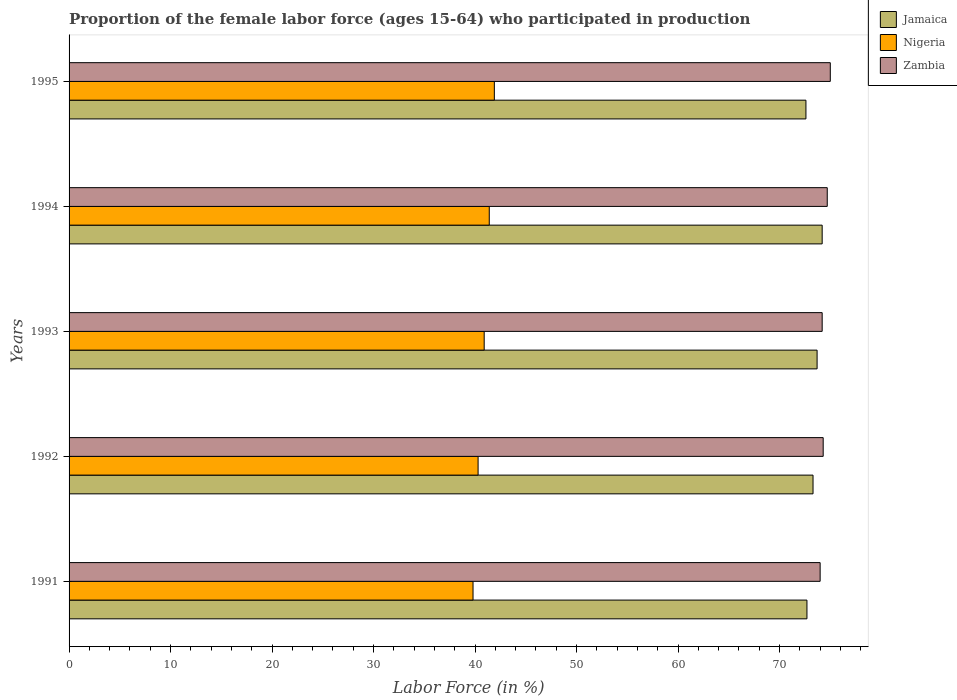How many groups of bars are there?
Provide a succinct answer. 5. How many bars are there on the 1st tick from the bottom?
Your answer should be very brief. 3. What is the label of the 1st group of bars from the top?
Keep it short and to the point. 1995. What is the proportion of the female labor force who participated in production in Nigeria in 1991?
Ensure brevity in your answer.  39.8. Across all years, what is the minimum proportion of the female labor force who participated in production in Zambia?
Offer a very short reply. 74. In which year was the proportion of the female labor force who participated in production in Nigeria maximum?
Keep it short and to the point. 1995. In which year was the proportion of the female labor force who participated in production in Zambia minimum?
Provide a succinct answer. 1991. What is the total proportion of the female labor force who participated in production in Nigeria in the graph?
Ensure brevity in your answer.  204.3. What is the difference between the proportion of the female labor force who participated in production in Jamaica in 1994 and that in 1995?
Offer a terse response. 1.6. What is the difference between the proportion of the female labor force who participated in production in Zambia in 1994 and the proportion of the female labor force who participated in production in Nigeria in 1991?
Keep it short and to the point. 34.9. What is the average proportion of the female labor force who participated in production in Zambia per year?
Keep it short and to the point. 74.44. In the year 1993, what is the difference between the proportion of the female labor force who participated in production in Zambia and proportion of the female labor force who participated in production in Nigeria?
Your answer should be very brief. 33.3. What is the ratio of the proportion of the female labor force who participated in production in Jamaica in 1991 to that in 1994?
Provide a short and direct response. 0.98. What is the difference between the highest and the lowest proportion of the female labor force who participated in production in Nigeria?
Your response must be concise. 2.1. In how many years, is the proportion of the female labor force who participated in production in Nigeria greater than the average proportion of the female labor force who participated in production in Nigeria taken over all years?
Offer a terse response. 3. Is the sum of the proportion of the female labor force who participated in production in Nigeria in 1993 and 1994 greater than the maximum proportion of the female labor force who participated in production in Zambia across all years?
Make the answer very short. Yes. What does the 3rd bar from the top in 1992 represents?
Make the answer very short. Jamaica. What does the 2nd bar from the bottom in 1994 represents?
Your answer should be very brief. Nigeria. Is it the case that in every year, the sum of the proportion of the female labor force who participated in production in Jamaica and proportion of the female labor force who participated in production in Nigeria is greater than the proportion of the female labor force who participated in production in Zambia?
Make the answer very short. Yes. How many bars are there?
Make the answer very short. 15. Are all the bars in the graph horizontal?
Make the answer very short. Yes. How many years are there in the graph?
Offer a very short reply. 5. What is the difference between two consecutive major ticks on the X-axis?
Your answer should be very brief. 10. Are the values on the major ticks of X-axis written in scientific E-notation?
Give a very brief answer. No. Where does the legend appear in the graph?
Offer a very short reply. Top right. How many legend labels are there?
Your answer should be compact. 3. What is the title of the graph?
Offer a very short reply. Proportion of the female labor force (ages 15-64) who participated in production. Does "Cabo Verde" appear as one of the legend labels in the graph?
Keep it short and to the point. No. What is the Labor Force (in %) in Jamaica in 1991?
Your answer should be very brief. 72.7. What is the Labor Force (in %) in Nigeria in 1991?
Provide a succinct answer. 39.8. What is the Labor Force (in %) of Jamaica in 1992?
Offer a terse response. 73.3. What is the Labor Force (in %) in Nigeria in 1992?
Your answer should be very brief. 40.3. What is the Labor Force (in %) of Zambia in 1992?
Your answer should be very brief. 74.3. What is the Labor Force (in %) in Jamaica in 1993?
Offer a terse response. 73.7. What is the Labor Force (in %) in Nigeria in 1993?
Provide a short and direct response. 40.9. What is the Labor Force (in %) of Zambia in 1993?
Provide a succinct answer. 74.2. What is the Labor Force (in %) in Jamaica in 1994?
Give a very brief answer. 74.2. What is the Labor Force (in %) of Nigeria in 1994?
Make the answer very short. 41.4. What is the Labor Force (in %) of Zambia in 1994?
Ensure brevity in your answer.  74.7. What is the Labor Force (in %) of Jamaica in 1995?
Offer a very short reply. 72.6. What is the Labor Force (in %) of Nigeria in 1995?
Offer a terse response. 41.9. What is the Labor Force (in %) in Zambia in 1995?
Offer a very short reply. 75. Across all years, what is the maximum Labor Force (in %) in Jamaica?
Keep it short and to the point. 74.2. Across all years, what is the maximum Labor Force (in %) of Nigeria?
Your response must be concise. 41.9. Across all years, what is the minimum Labor Force (in %) of Jamaica?
Your answer should be compact. 72.6. Across all years, what is the minimum Labor Force (in %) of Nigeria?
Your answer should be compact. 39.8. Across all years, what is the minimum Labor Force (in %) of Zambia?
Ensure brevity in your answer.  74. What is the total Labor Force (in %) of Jamaica in the graph?
Offer a terse response. 366.5. What is the total Labor Force (in %) in Nigeria in the graph?
Offer a terse response. 204.3. What is the total Labor Force (in %) in Zambia in the graph?
Give a very brief answer. 372.2. What is the difference between the Labor Force (in %) of Jamaica in 1991 and that in 1992?
Give a very brief answer. -0.6. What is the difference between the Labor Force (in %) in Zambia in 1991 and that in 1992?
Your response must be concise. -0.3. What is the difference between the Labor Force (in %) in Jamaica in 1991 and that in 1993?
Offer a terse response. -1. What is the difference between the Labor Force (in %) of Nigeria in 1991 and that in 1993?
Ensure brevity in your answer.  -1.1. What is the difference between the Labor Force (in %) of Zambia in 1991 and that in 1993?
Ensure brevity in your answer.  -0.2. What is the difference between the Labor Force (in %) of Jamaica in 1991 and that in 1994?
Give a very brief answer. -1.5. What is the difference between the Labor Force (in %) in Nigeria in 1991 and that in 1994?
Keep it short and to the point. -1.6. What is the difference between the Labor Force (in %) in Zambia in 1991 and that in 1994?
Your answer should be very brief. -0.7. What is the difference between the Labor Force (in %) in Nigeria in 1991 and that in 1995?
Ensure brevity in your answer.  -2.1. What is the difference between the Labor Force (in %) of Zambia in 1991 and that in 1995?
Give a very brief answer. -1. What is the difference between the Labor Force (in %) in Zambia in 1992 and that in 1993?
Keep it short and to the point. 0.1. What is the difference between the Labor Force (in %) of Jamaica in 1992 and that in 1994?
Your answer should be compact. -0.9. What is the difference between the Labor Force (in %) in Nigeria in 1992 and that in 1995?
Make the answer very short. -1.6. What is the difference between the Labor Force (in %) of Zambia in 1992 and that in 1995?
Provide a succinct answer. -0.7. What is the difference between the Labor Force (in %) of Jamaica in 1993 and that in 1994?
Offer a very short reply. -0.5. What is the difference between the Labor Force (in %) of Zambia in 1993 and that in 1994?
Your answer should be very brief. -0.5. What is the difference between the Labor Force (in %) of Nigeria in 1993 and that in 1995?
Keep it short and to the point. -1. What is the difference between the Labor Force (in %) in Jamaica in 1991 and the Labor Force (in %) in Nigeria in 1992?
Provide a short and direct response. 32.4. What is the difference between the Labor Force (in %) in Jamaica in 1991 and the Labor Force (in %) in Zambia in 1992?
Make the answer very short. -1.6. What is the difference between the Labor Force (in %) of Nigeria in 1991 and the Labor Force (in %) of Zambia in 1992?
Your answer should be very brief. -34.5. What is the difference between the Labor Force (in %) of Jamaica in 1991 and the Labor Force (in %) of Nigeria in 1993?
Your answer should be very brief. 31.8. What is the difference between the Labor Force (in %) of Nigeria in 1991 and the Labor Force (in %) of Zambia in 1993?
Provide a succinct answer. -34.4. What is the difference between the Labor Force (in %) in Jamaica in 1991 and the Labor Force (in %) in Nigeria in 1994?
Offer a terse response. 31.3. What is the difference between the Labor Force (in %) of Jamaica in 1991 and the Labor Force (in %) of Zambia in 1994?
Provide a short and direct response. -2. What is the difference between the Labor Force (in %) of Nigeria in 1991 and the Labor Force (in %) of Zambia in 1994?
Make the answer very short. -34.9. What is the difference between the Labor Force (in %) in Jamaica in 1991 and the Labor Force (in %) in Nigeria in 1995?
Keep it short and to the point. 30.8. What is the difference between the Labor Force (in %) in Jamaica in 1991 and the Labor Force (in %) in Zambia in 1995?
Offer a terse response. -2.3. What is the difference between the Labor Force (in %) in Nigeria in 1991 and the Labor Force (in %) in Zambia in 1995?
Provide a succinct answer. -35.2. What is the difference between the Labor Force (in %) in Jamaica in 1992 and the Labor Force (in %) in Nigeria in 1993?
Make the answer very short. 32.4. What is the difference between the Labor Force (in %) in Jamaica in 1992 and the Labor Force (in %) in Zambia in 1993?
Offer a terse response. -0.9. What is the difference between the Labor Force (in %) of Nigeria in 1992 and the Labor Force (in %) of Zambia in 1993?
Offer a very short reply. -33.9. What is the difference between the Labor Force (in %) of Jamaica in 1992 and the Labor Force (in %) of Nigeria in 1994?
Provide a short and direct response. 31.9. What is the difference between the Labor Force (in %) in Nigeria in 1992 and the Labor Force (in %) in Zambia in 1994?
Give a very brief answer. -34.4. What is the difference between the Labor Force (in %) of Jamaica in 1992 and the Labor Force (in %) of Nigeria in 1995?
Your response must be concise. 31.4. What is the difference between the Labor Force (in %) in Nigeria in 1992 and the Labor Force (in %) in Zambia in 1995?
Give a very brief answer. -34.7. What is the difference between the Labor Force (in %) in Jamaica in 1993 and the Labor Force (in %) in Nigeria in 1994?
Ensure brevity in your answer.  32.3. What is the difference between the Labor Force (in %) of Jamaica in 1993 and the Labor Force (in %) of Zambia in 1994?
Offer a terse response. -1. What is the difference between the Labor Force (in %) of Nigeria in 1993 and the Labor Force (in %) of Zambia in 1994?
Provide a short and direct response. -33.8. What is the difference between the Labor Force (in %) in Jamaica in 1993 and the Labor Force (in %) in Nigeria in 1995?
Provide a short and direct response. 31.8. What is the difference between the Labor Force (in %) of Jamaica in 1993 and the Labor Force (in %) of Zambia in 1995?
Offer a terse response. -1.3. What is the difference between the Labor Force (in %) of Nigeria in 1993 and the Labor Force (in %) of Zambia in 1995?
Your answer should be compact. -34.1. What is the difference between the Labor Force (in %) in Jamaica in 1994 and the Labor Force (in %) in Nigeria in 1995?
Offer a very short reply. 32.3. What is the difference between the Labor Force (in %) in Jamaica in 1994 and the Labor Force (in %) in Zambia in 1995?
Your answer should be compact. -0.8. What is the difference between the Labor Force (in %) in Nigeria in 1994 and the Labor Force (in %) in Zambia in 1995?
Offer a very short reply. -33.6. What is the average Labor Force (in %) of Jamaica per year?
Your response must be concise. 73.3. What is the average Labor Force (in %) in Nigeria per year?
Your response must be concise. 40.86. What is the average Labor Force (in %) of Zambia per year?
Provide a short and direct response. 74.44. In the year 1991, what is the difference between the Labor Force (in %) in Jamaica and Labor Force (in %) in Nigeria?
Give a very brief answer. 32.9. In the year 1991, what is the difference between the Labor Force (in %) of Nigeria and Labor Force (in %) of Zambia?
Your response must be concise. -34.2. In the year 1992, what is the difference between the Labor Force (in %) in Jamaica and Labor Force (in %) in Nigeria?
Offer a very short reply. 33. In the year 1992, what is the difference between the Labor Force (in %) of Jamaica and Labor Force (in %) of Zambia?
Make the answer very short. -1. In the year 1992, what is the difference between the Labor Force (in %) in Nigeria and Labor Force (in %) in Zambia?
Ensure brevity in your answer.  -34. In the year 1993, what is the difference between the Labor Force (in %) in Jamaica and Labor Force (in %) in Nigeria?
Ensure brevity in your answer.  32.8. In the year 1993, what is the difference between the Labor Force (in %) of Jamaica and Labor Force (in %) of Zambia?
Provide a succinct answer. -0.5. In the year 1993, what is the difference between the Labor Force (in %) in Nigeria and Labor Force (in %) in Zambia?
Offer a terse response. -33.3. In the year 1994, what is the difference between the Labor Force (in %) in Jamaica and Labor Force (in %) in Nigeria?
Your answer should be very brief. 32.8. In the year 1994, what is the difference between the Labor Force (in %) in Nigeria and Labor Force (in %) in Zambia?
Offer a very short reply. -33.3. In the year 1995, what is the difference between the Labor Force (in %) of Jamaica and Labor Force (in %) of Nigeria?
Give a very brief answer. 30.7. In the year 1995, what is the difference between the Labor Force (in %) in Jamaica and Labor Force (in %) in Zambia?
Ensure brevity in your answer.  -2.4. In the year 1995, what is the difference between the Labor Force (in %) in Nigeria and Labor Force (in %) in Zambia?
Your answer should be compact. -33.1. What is the ratio of the Labor Force (in %) of Jamaica in 1991 to that in 1992?
Provide a succinct answer. 0.99. What is the ratio of the Labor Force (in %) of Nigeria in 1991 to that in 1992?
Offer a terse response. 0.99. What is the ratio of the Labor Force (in %) in Zambia in 1991 to that in 1992?
Ensure brevity in your answer.  1. What is the ratio of the Labor Force (in %) in Jamaica in 1991 to that in 1993?
Give a very brief answer. 0.99. What is the ratio of the Labor Force (in %) of Nigeria in 1991 to that in 1993?
Keep it short and to the point. 0.97. What is the ratio of the Labor Force (in %) in Zambia in 1991 to that in 1993?
Your answer should be compact. 1. What is the ratio of the Labor Force (in %) in Jamaica in 1991 to that in 1994?
Your response must be concise. 0.98. What is the ratio of the Labor Force (in %) of Nigeria in 1991 to that in 1994?
Provide a succinct answer. 0.96. What is the ratio of the Labor Force (in %) in Zambia in 1991 to that in 1994?
Provide a succinct answer. 0.99. What is the ratio of the Labor Force (in %) of Jamaica in 1991 to that in 1995?
Offer a terse response. 1. What is the ratio of the Labor Force (in %) of Nigeria in 1991 to that in 1995?
Ensure brevity in your answer.  0.95. What is the ratio of the Labor Force (in %) of Zambia in 1991 to that in 1995?
Keep it short and to the point. 0.99. What is the ratio of the Labor Force (in %) in Zambia in 1992 to that in 1993?
Provide a short and direct response. 1. What is the ratio of the Labor Force (in %) of Jamaica in 1992 to that in 1994?
Provide a succinct answer. 0.99. What is the ratio of the Labor Force (in %) of Nigeria in 1992 to that in 1994?
Give a very brief answer. 0.97. What is the ratio of the Labor Force (in %) in Jamaica in 1992 to that in 1995?
Give a very brief answer. 1.01. What is the ratio of the Labor Force (in %) of Nigeria in 1992 to that in 1995?
Give a very brief answer. 0.96. What is the ratio of the Labor Force (in %) of Zambia in 1992 to that in 1995?
Offer a terse response. 0.99. What is the ratio of the Labor Force (in %) in Nigeria in 1993 to that in 1994?
Offer a very short reply. 0.99. What is the ratio of the Labor Force (in %) of Jamaica in 1993 to that in 1995?
Keep it short and to the point. 1.02. What is the ratio of the Labor Force (in %) of Nigeria in 1993 to that in 1995?
Your response must be concise. 0.98. What is the ratio of the Labor Force (in %) in Zambia in 1993 to that in 1995?
Provide a short and direct response. 0.99. What is the ratio of the Labor Force (in %) in Jamaica in 1994 to that in 1995?
Your answer should be compact. 1.02. What is the ratio of the Labor Force (in %) in Nigeria in 1994 to that in 1995?
Offer a very short reply. 0.99. What is the difference between the highest and the second highest Labor Force (in %) in Nigeria?
Your answer should be very brief. 0.5. What is the difference between the highest and the lowest Labor Force (in %) of Jamaica?
Offer a very short reply. 1.6. What is the difference between the highest and the lowest Labor Force (in %) in Nigeria?
Provide a short and direct response. 2.1. 